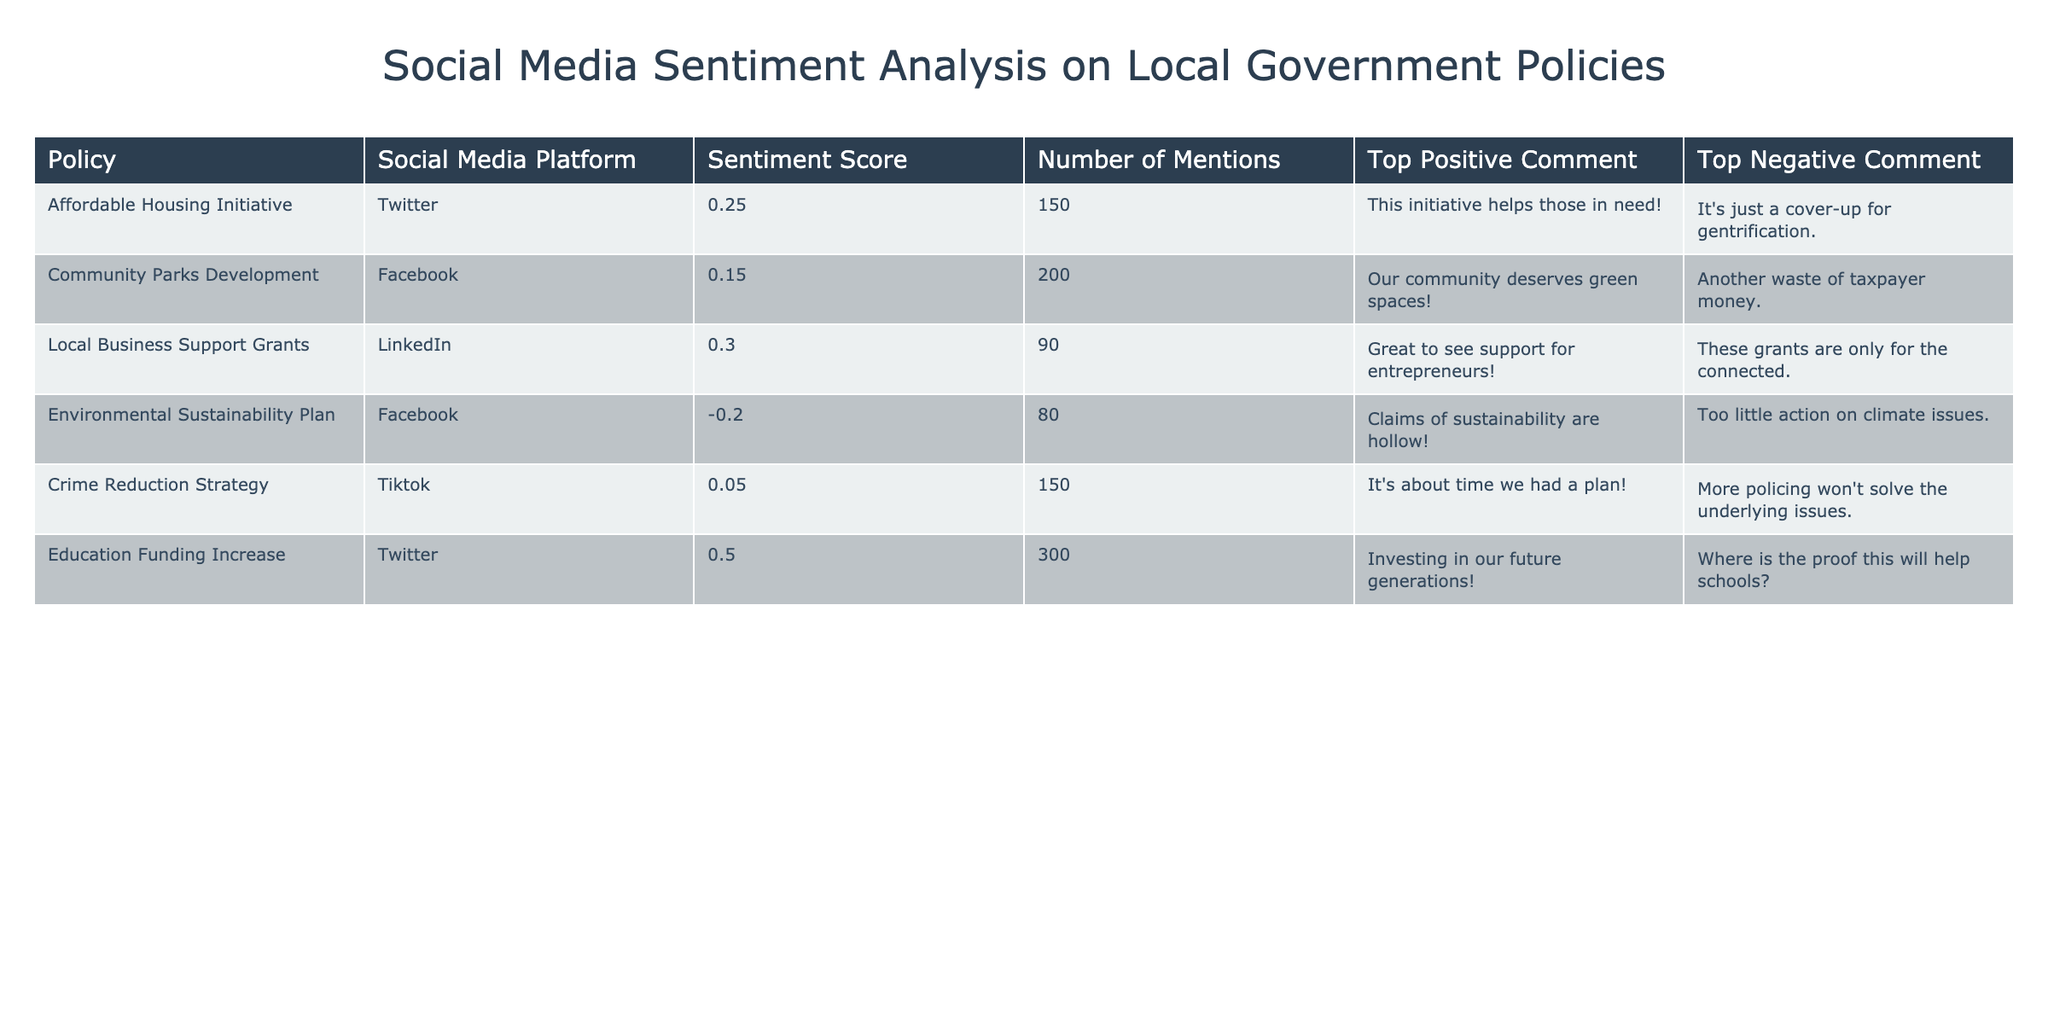What is the sentiment score for the Education Funding Increase policy? The sentiment score is listed directly under the "Sentiment Score" column for the "Education Funding Increase" policy. According to the table, it is 0.50.
Answer: 0.50 Which policy has the highest number of mentions on social media? By examining the "Number of Mentions" column, we find that the "Education Funding Increase" has the highest mention count, totaling 300 mentions.
Answer: Education Funding Increase Is there a negative sentiment score associated with the Affordable Housing Initiative? The sentiment score for the "Affordable Housing Initiative" is 0.25, which is positive. Hence, there is no negative sentiment score associated with this policy.
Answer: No What is the average sentiment score of all policies listed in the table? To calculate the average, add the sentiment scores: 0.25 + 0.15 + 0.30 - 0.20 + 0.05 + 0.50 = 1.05. There are 6 policies, so divide the total by 6. Thus, 1.05 / 6 = 0.175.
Answer: 0.175 Which policy has the most positive top comment? The "Education Funding Increase" policy has the top positive comment: "Investing in our future generations!" and it also has the highest sentiment score. Thus, it ranks highest in positivity.
Answer: Education Funding Increase Do both the Environmental Sustainability Plan and the Crime Reduction Strategy have negative sentiment scores? The "Environmental Sustainability Plan" has a score of -0.20, which is negative, and the "Crime Reduction Strategy" has a score of 0.05, which is positive. Therefore, only one policy has a negative sentiment score.
Answer: No What is the sentiment score difference between the Local Business Support Grants and the Community Parks Development policy? The sentiment score for "Local Business Support Grants" is 0.30 and for "Community Parks Development" is 0.15. The difference is 0.30 - 0.15 = 0.15.
Answer: 0.15 Which social media platform has the highest average sentiment score based on the policies listed? The platforms and their respective sentiment scores are as follows: Twitter (0.25, 0.50), Facebook (0.15, -0.20), LinkedIn (0.30), and TikTok (0.05). Calculate the average for each: Twitter: (0.25 + 0.50)/2 = 0.375, Facebook: (0.15 - 0.20)/2 = -0.025, LinkedIn: 0.30, TikTok: 0.05. The highest average comes from Twitter at 0.375.
Answer: Twitter How many total mentions are there for the Environmental Sustainability Plan and the Local Business Support Grants combined? The "Environmental Sustainability Plan" has 80 mentions and "Local Business Support Grants" has 90 mentions. Therefore, the total is 80 + 90 = 170 mentions combined.
Answer: 170 